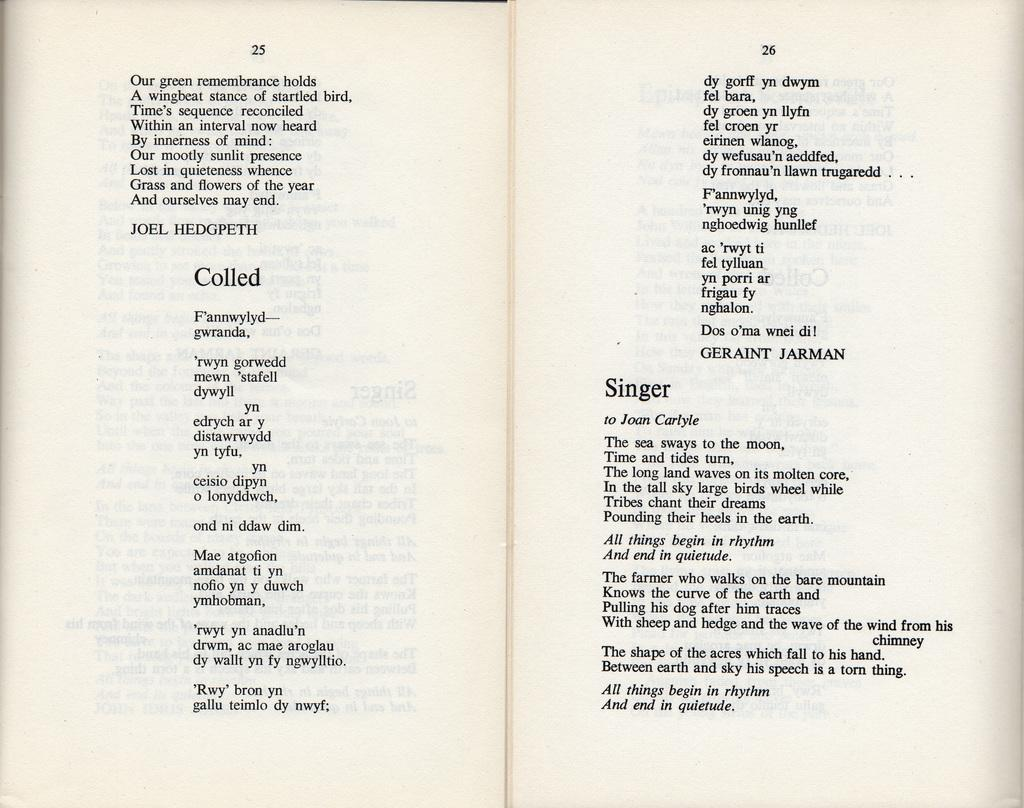Provide a one-sentence caption for the provided image. The Poems "Colled" by Joel Hedgpeth and the Poem "Singer" by Joan Carlyle are written. 